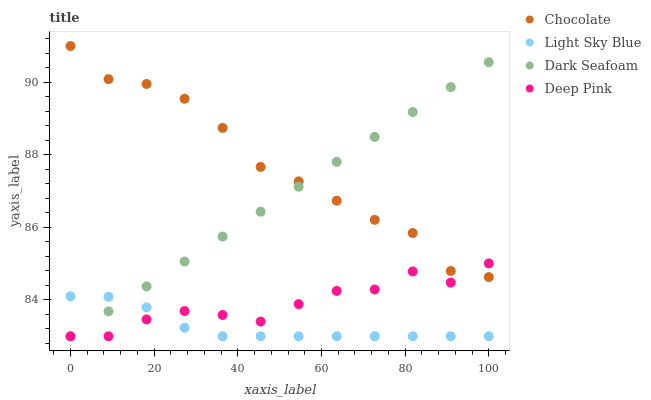Does Light Sky Blue have the minimum area under the curve?
Answer yes or no. Yes. Does Chocolate have the maximum area under the curve?
Answer yes or no. Yes. Does Deep Pink have the minimum area under the curve?
Answer yes or no. No. Does Deep Pink have the maximum area under the curve?
Answer yes or no. No. Is Dark Seafoam the smoothest?
Answer yes or no. Yes. Is Deep Pink the roughest?
Answer yes or no. Yes. Is Light Sky Blue the smoothest?
Answer yes or no. No. Is Light Sky Blue the roughest?
Answer yes or no. No. Does Dark Seafoam have the lowest value?
Answer yes or no. Yes. Does Chocolate have the lowest value?
Answer yes or no. No. Does Chocolate have the highest value?
Answer yes or no. Yes. Does Deep Pink have the highest value?
Answer yes or no. No. Is Light Sky Blue less than Chocolate?
Answer yes or no. Yes. Is Chocolate greater than Light Sky Blue?
Answer yes or no. Yes. Does Chocolate intersect Dark Seafoam?
Answer yes or no. Yes. Is Chocolate less than Dark Seafoam?
Answer yes or no. No. Is Chocolate greater than Dark Seafoam?
Answer yes or no. No. Does Light Sky Blue intersect Chocolate?
Answer yes or no. No. 